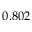<formula> <loc_0><loc_0><loc_500><loc_500>0 . 8 0 2</formula> 